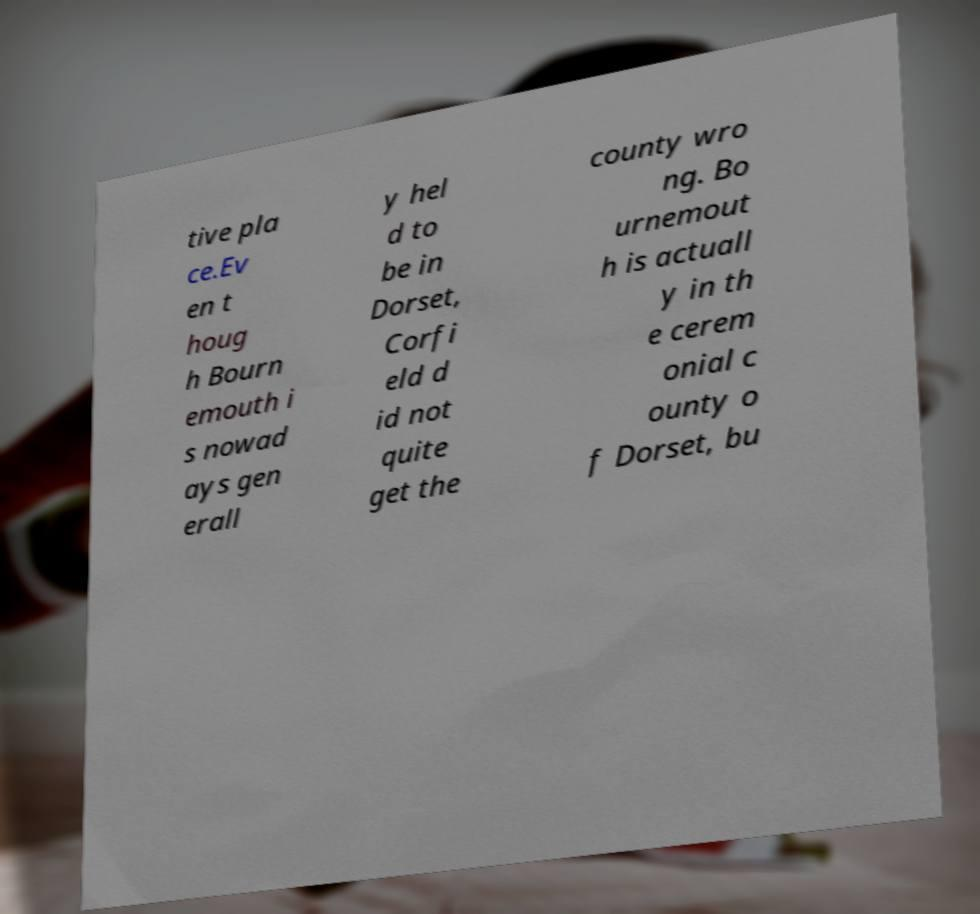What messages or text are displayed in this image? I need them in a readable, typed format. tive pla ce.Ev en t houg h Bourn emouth i s nowad ays gen erall y hel d to be in Dorset, Corfi eld d id not quite get the county wro ng. Bo urnemout h is actuall y in th e cerem onial c ounty o f Dorset, bu 